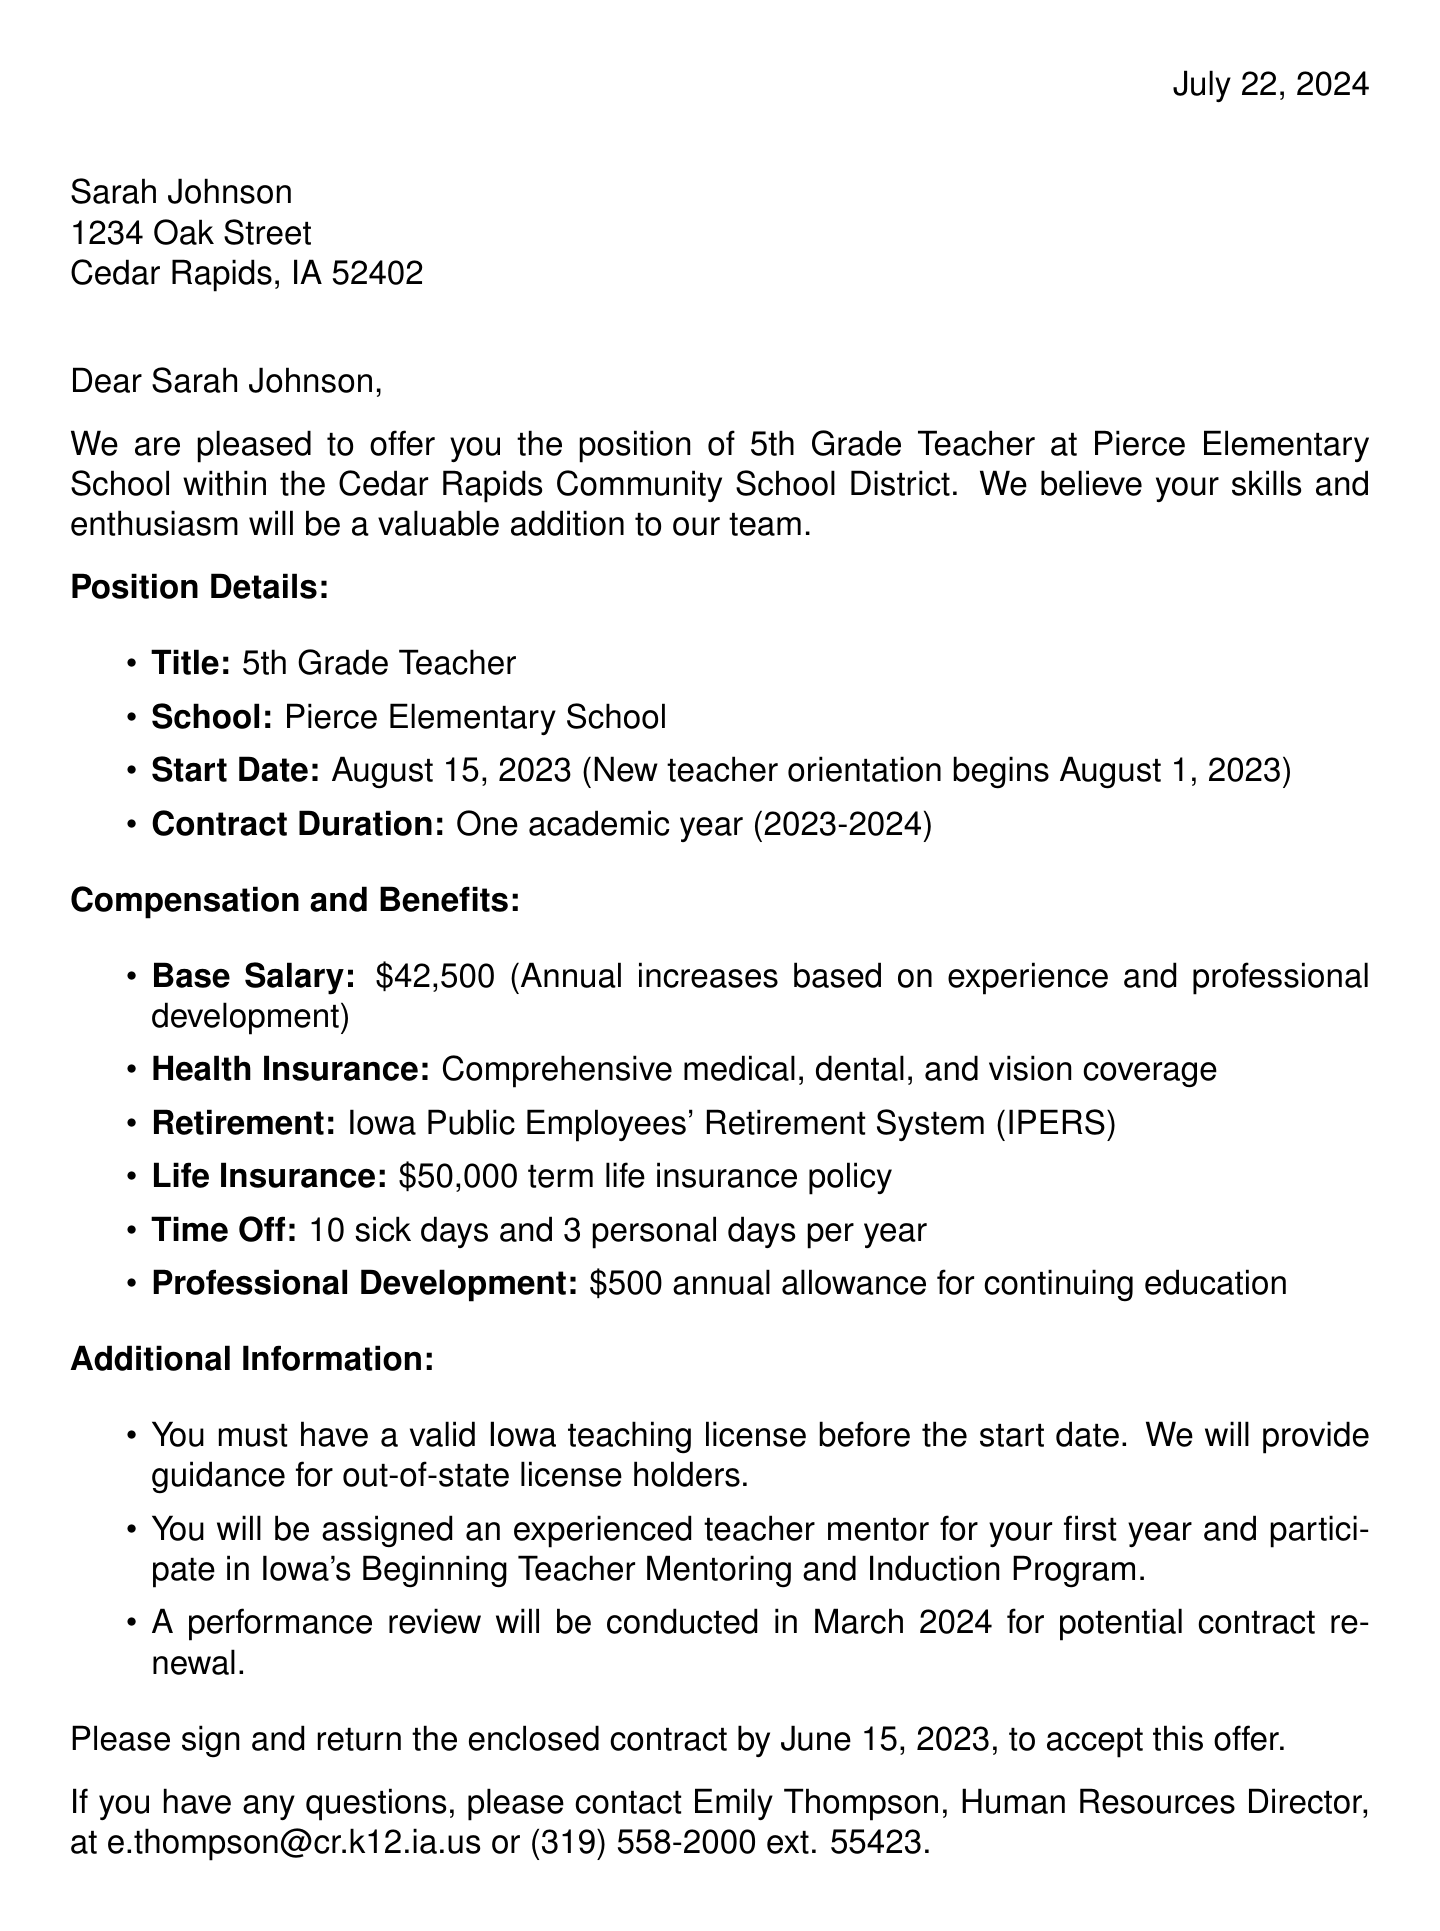What is the name of the school district? The school district is clearly stated in the letter's letterhead.
Answer: Cedar Rapids Community School District What is the job title offered? The position title is specified in the document under position details.
Answer: 5th Grade Teacher What is the start date for the position? The start date is provided within the position details section of the letter.
Answer: August 15, 2023 What is the base salary for the teaching position? The salary information is mentioned in the compensation section of the letter.
Answer: $42,500 How many sick days are provided per year? The benefits section of the document details the time-off benefits.
Answer: 10 sick days What additional support is offered to new teachers? The document outlines specific support programs for new teachers under additional information.
Answer: Mentor Program What is the acceptance deadline for the contract? The acceptance deadline is specified in the closing section of the letter.
Answer: June 15, 2023 Who is the contact person for questions? The contact information for inquiries is provided near the end of the letter.
Answer: Emily Thompson What is the retirement plan mentioned in the letter? The retirement benefits are outlined in the compensation and benefits section.
Answer: Iowa Public Employees' Retirement System (IPERS) 